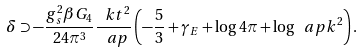Convert formula to latex. <formula><loc_0><loc_0><loc_500><loc_500>\delta \supset - \frac { g _ { s } ^ { 2 } \beta G _ { 4 } } { 2 4 \pi ^ { 3 } } \frac { \ k t ^ { 2 } } { \ a p } \left ( - \frac { 5 } { 3 } + \gamma _ { E } + \log 4 \pi + \log \ a p k ^ { 2 } \right ) .</formula> 